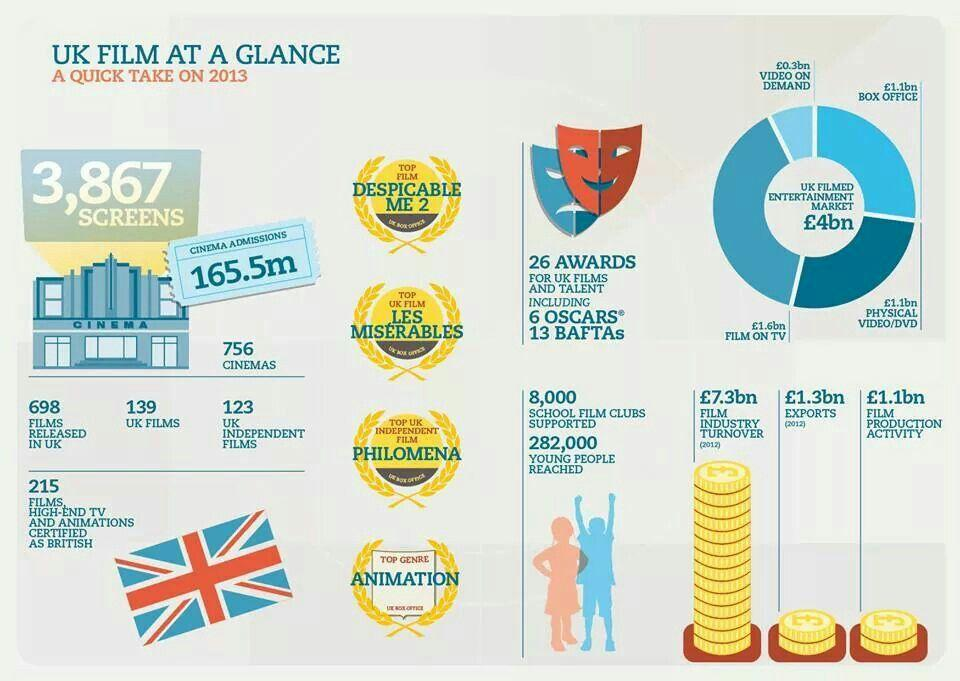Outline some significant characteristics in this image. Eight thousand school film clubs are currently supported. The amount for film on TV in the UK filmed entertainment market is estimated to be £1.6 billion. In the United Kingdom, a total of 698 films have been released. The amount for film production activity is estimated to be £1.1 billion. The video on demand market in the UK filmed entertainment industry is worth approximately £0.3 billion. 